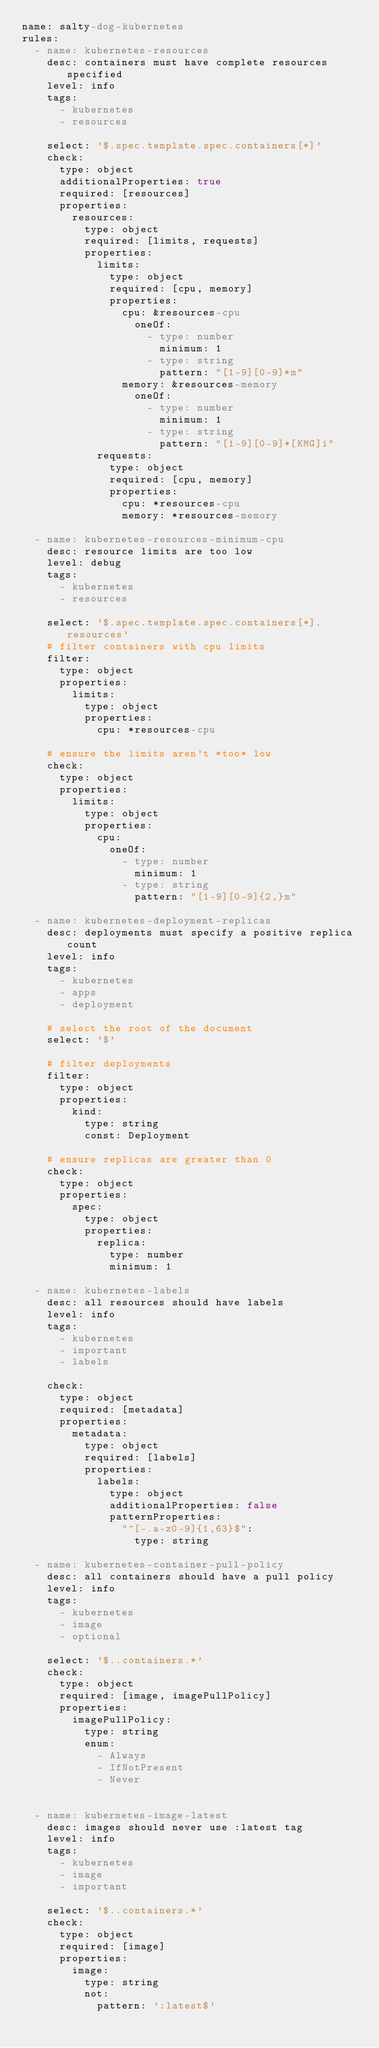<code> <loc_0><loc_0><loc_500><loc_500><_YAML_>name: salty-dog-kubernetes
rules:
  - name: kubernetes-resources
    desc: containers must have complete resources specified
    level: info
    tags:
      - kubernetes
      - resources

    select: '$.spec.template.spec.containers[*]'
    check:
      type: object
      additionalProperties: true
      required: [resources]
      properties:
        resources:
          type: object
          required: [limits, requests]
          properties:
            limits:
              type: object
              required: [cpu, memory]
              properties:
                cpu: &resources-cpu
                  oneOf:
                    - type: number
                      minimum: 1
                    - type: string
                      pattern: "[1-9][0-9]*m"
                memory: &resources-memory
                  oneOf:
                    - type: number
                      minimum: 1
                    - type: string
                      pattern: "[1-9][0-9]*[KMG]i"
            requests:
              type: object
              required: [cpu, memory]
              properties:
                cpu: *resources-cpu
                memory: *resources-memory

  - name: kubernetes-resources-minimum-cpu
    desc: resource limits are too low
    level: debug
    tags:
      - kubernetes
      - resources

    select: '$.spec.template.spec.containers[*].resources'
    # filter containers with cpu limits
    filter:
      type: object
      properties:
        limits:
          type: object
          properties:
            cpu: *resources-cpu

    # ensure the limits aren't *too* low
    check:
      type: object
      properties:
        limits:
          type: object
          properties:
            cpu:
              oneOf:
                - type: number
                  minimum: 1
                - type: string
                  pattern: "[1-9][0-9]{2,}m"

  - name: kubernetes-deployment-replicas
    desc: deployments must specify a positive replica count
    level: info
    tags:
      - kubernetes
      - apps
      - deployment

    # select the root of the document
    select: '$'

    # filter deployments
    filter:
      type: object
      properties:
        kind:
          type: string
          const: Deployment

    # ensure replicas are greater than 0
    check:
      type: object
      properties:
        spec:
          type: object
          properties:
            replica:
              type: number
              minimum: 1

  - name: kubernetes-labels
    desc: all resources should have labels
    level: info
    tags:
      - kubernetes
      - important
      - labels

    check:
      type: object
      required: [metadata]
      properties:
        metadata:
          type: object
          required: [labels]
          properties:
            labels:
              type: object
              additionalProperties: false
              patternProperties:
                "^[-.a-z0-9]{1,63}$":
                  type: string

  - name: kubernetes-container-pull-policy
    desc: all containers should have a pull policy
    level: info
    tags:
      - kubernetes
      - image
      - optional

    select: '$..containers.*'
    check:
      type: object
      required: [image, imagePullPolicy]
      properties:
        imagePullPolicy:
          type: string
          enum:
            - Always
            - IfNotPresent
            - Never


  - name: kubernetes-image-latest
    desc: images should never use :latest tag
    level: info
    tags:
      - kubernetes
      - image
      - important

    select: '$..containers.*'
    check:
      type: object
      required: [image]
      properties:
        image:
          type: string
          not:
            pattern: ':latest$'</code> 